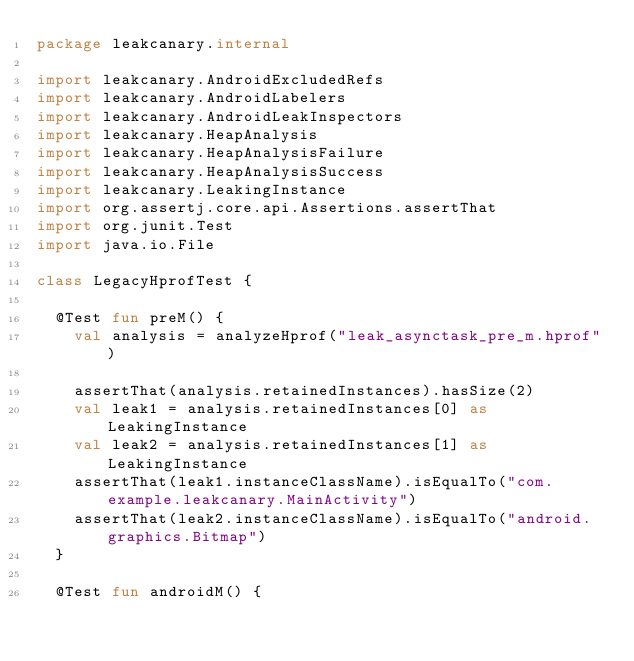<code> <loc_0><loc_0><loc_500><loc_500><_Kotlin_>package leakcanary.internal

import leakcanary.AndroidExcludedRefs
import leakcanary.AndroidLabelers
import leakcanary.AndroidLeakInspectors
import leakcanary.HeapAnalysis
import leakcanary.HeapAnalysisFailure
import leakcanary.HeapAnalysisSuccess
import leakcanary.LeakingInstance
import org.assertj.core.api.Assertions.assertThat
import org.junit.Test
import java.io.File

class LegacyHprofTest {

  @Test fun preM() {
    val analysis = analyzeHprof("leak_asynctask_pre_m.hprof")

    assertThat(analysis.retainedInstances).hasSize(2)
    val leak1 = analysis.retainedInstances[0] as LeakingInstance
    val leak2 = analysis.retainedInstances[1] as LeakingInstance
    assertThat(leak1.instanceClassName).isEqualTo("com.example.leakcanary.MainActivity")
    assertThat(leak2.instanceClassName).isEqualTo("android.graphics.Bitmap")
  }

  @Test fun androidM() {</code> 